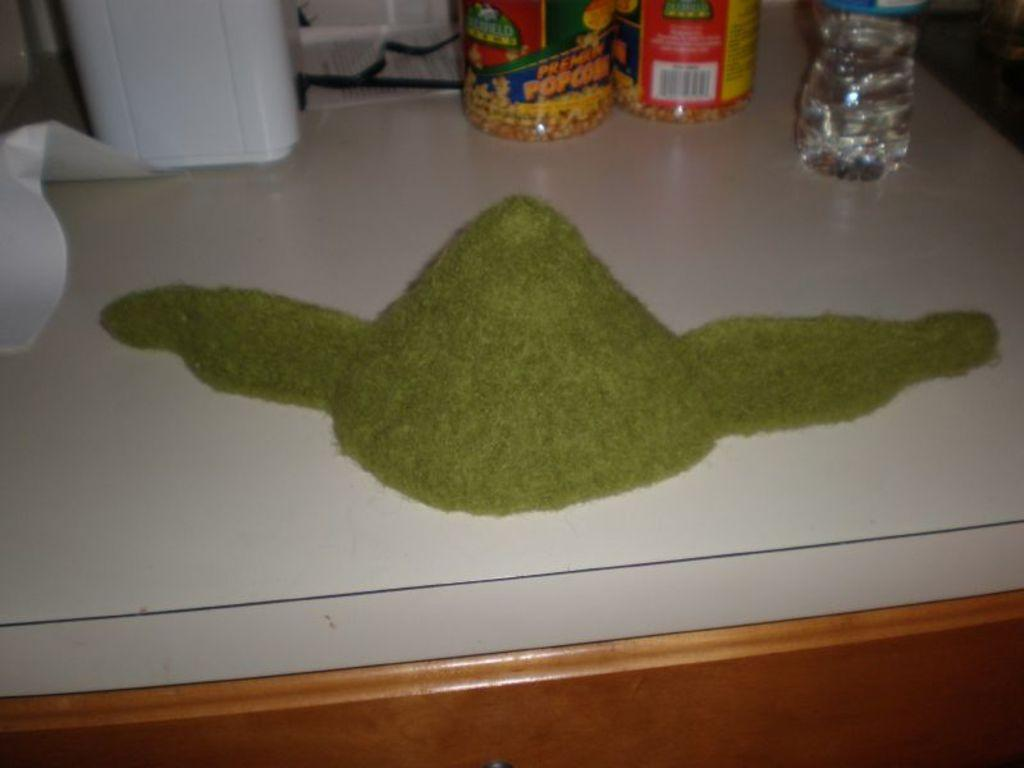What is the main object in the center of the image? There is a table in the center of the image. What is placed on the table? There is a bottle on the table. What is written on the bottle? The bottle is labeled "Popcorn". What else can be seen on the table? There is a cap on the table. Are there any other objects on the table? Yes, there are additional objects on the table. Can you see the yoke of the egg in the image? There is no egg or yoke present in the image. How many hands are visible in the image? There are no hands visible in the image. 